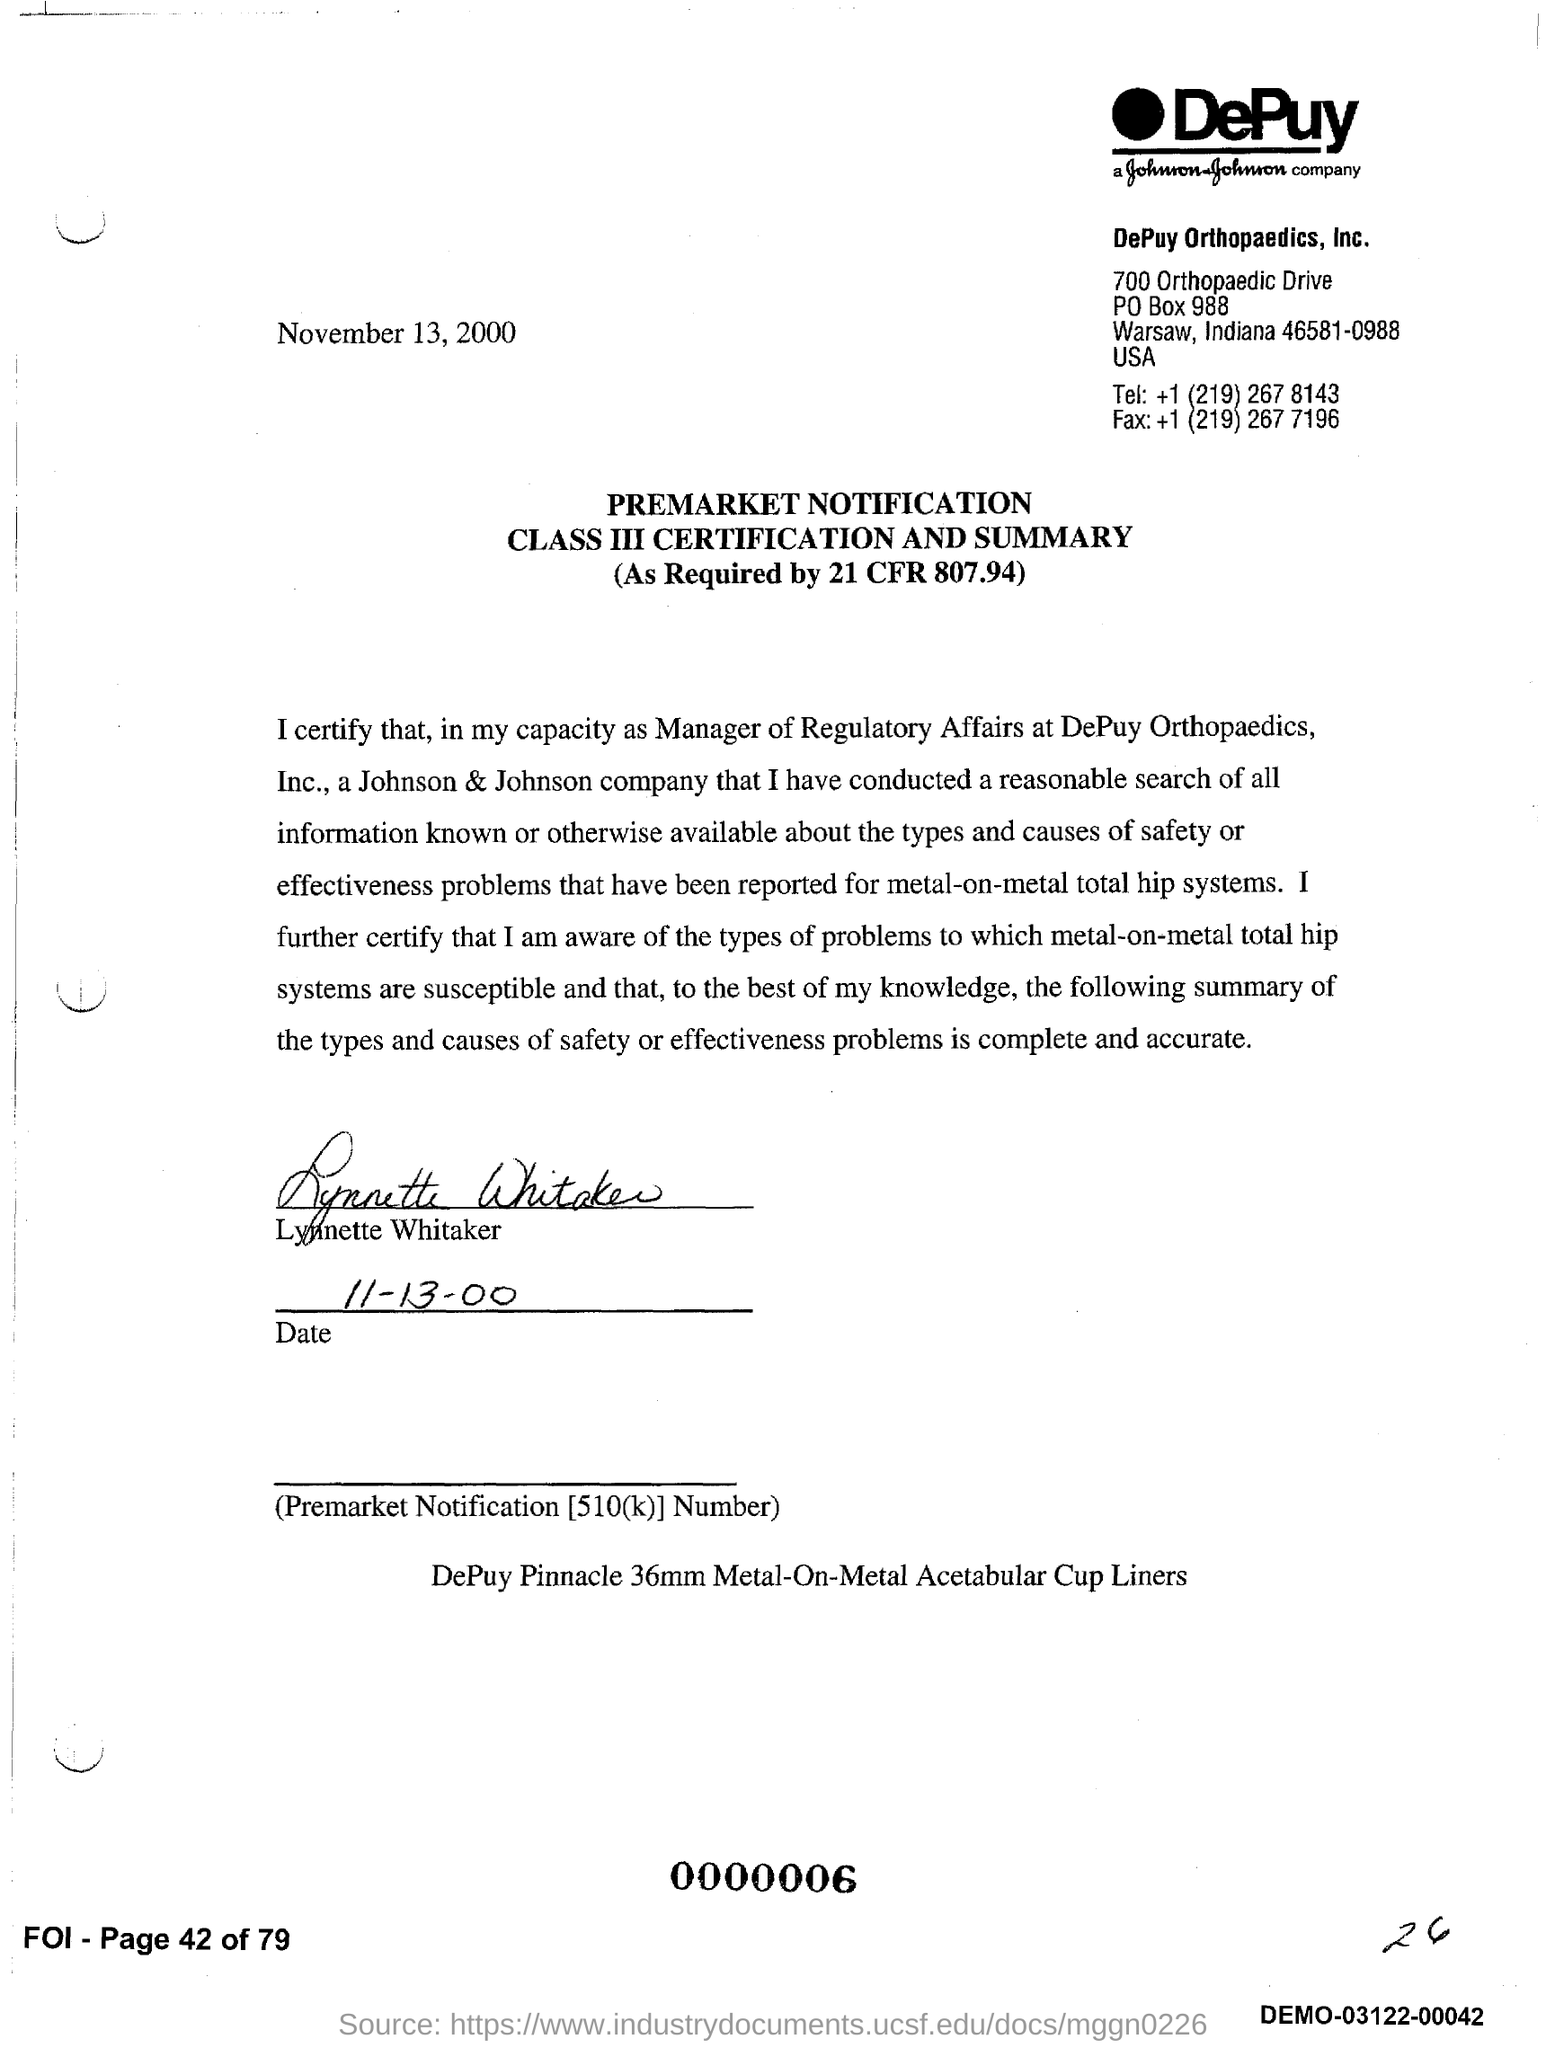Who has signed this notification?
Provide a succinct answer. Lynnette Whitaker. What is the signature date given in this notification?
Keep it short and to the point. 11-13-00. 